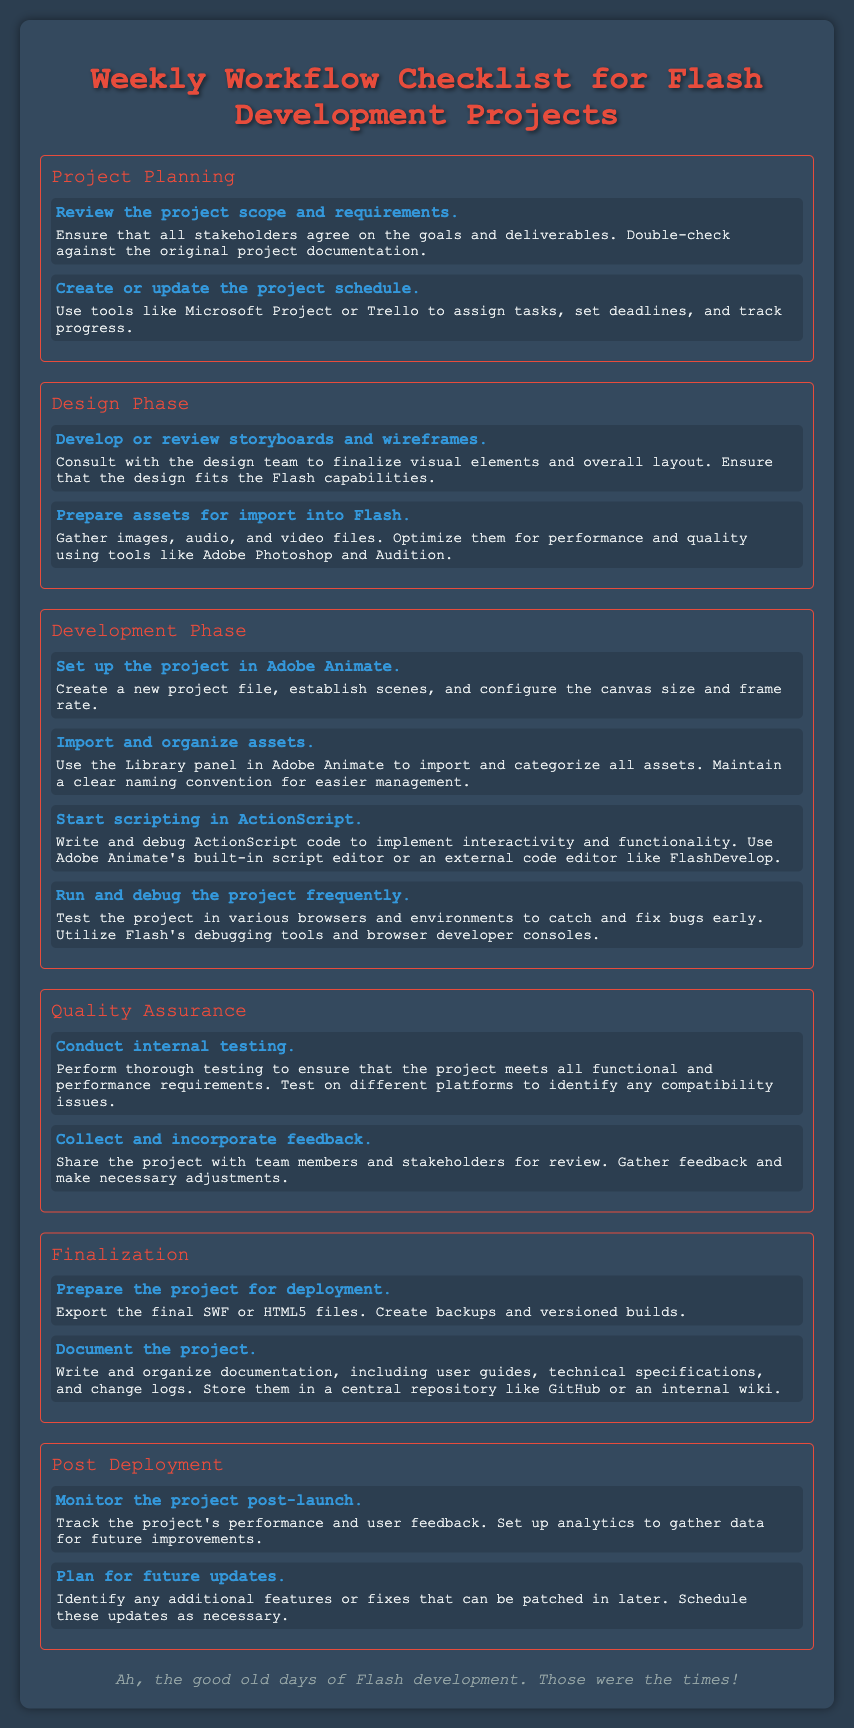What is the title of the document? The document is titled "Weekly Workflow Checklist for Flash Development Projects."
Answer: Weekly Workflow Checklist for Flash Development Projects How many sections are in the document? The document has five sections: Project Planning, Design Phase, Development Phase, Quality Assurance, Finalization, and Post Deployment.
Answer: Seven In what phase should assets be prepared for import into Flash? Preparing assets is part of the Design Phase, as stated under the design section.
Answer: Design Phase What tool can be used to set up the project in Adobe Animate? Adobe Animate is listed as the tool to set up the project, according to the Development Phase tasks.
Answer: Adobe Animate What must be done after the project is launched? Monitoring the project post-launch is indicated as a necessary task in the Post Deployment section.
Answer: Monitor the project post-launch How should feedback be handled during the Quality Assurance phase? Feedback should be collected and incorporated based on the task described in the Quality Assurance section.
Answer: Collect and incorporate feedback Which scripting language is mentioned for implementing interactivity? ActionScript is mentioned as the scripting language used for implementing interactivity during the Development Phase.
Answer: ActionScript 